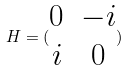Convert formula to latex. <formula><loc_0><loc_0><loc_500><loc_500>H = ( \begin{matrix} 0 & - i \\ i & 0 \end{matrix} )</formula> 